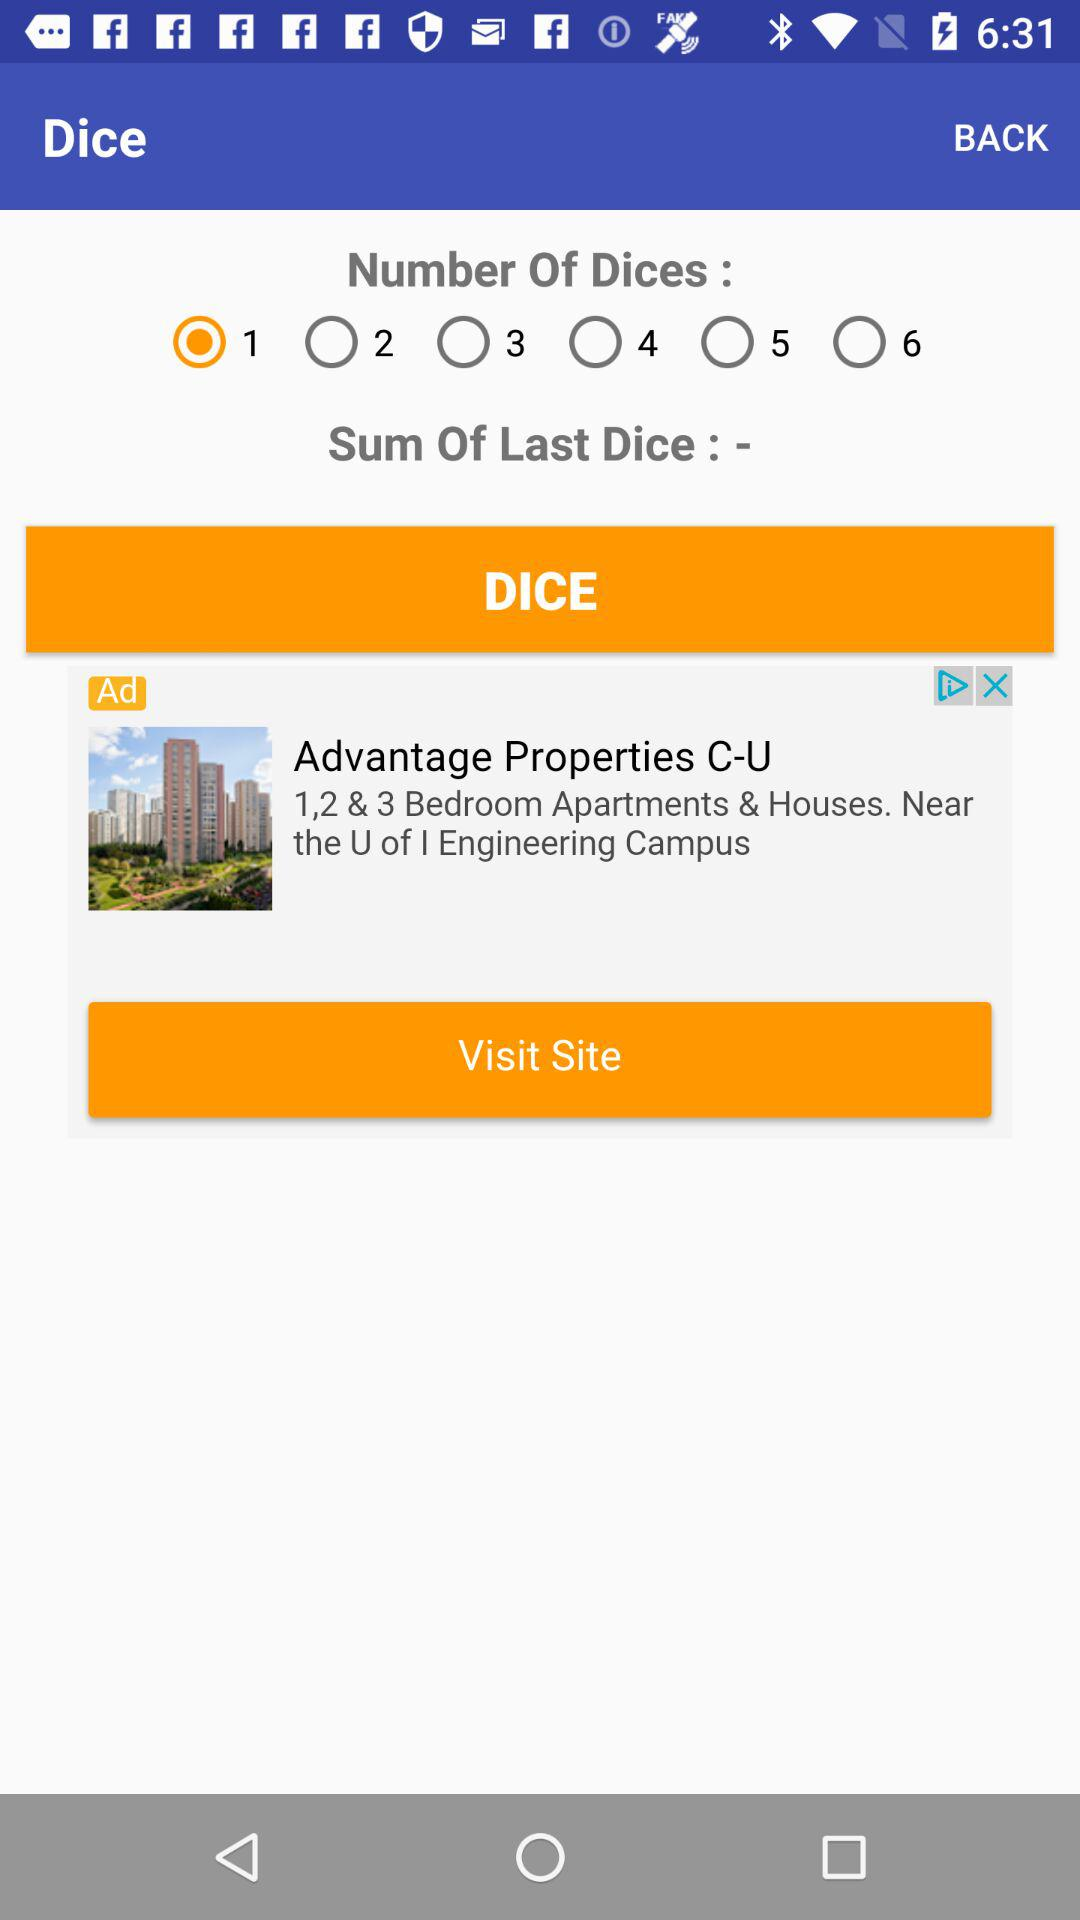What is the maximum number of dice that can be rolled?
Answer the question using a single word or phrase. 6 